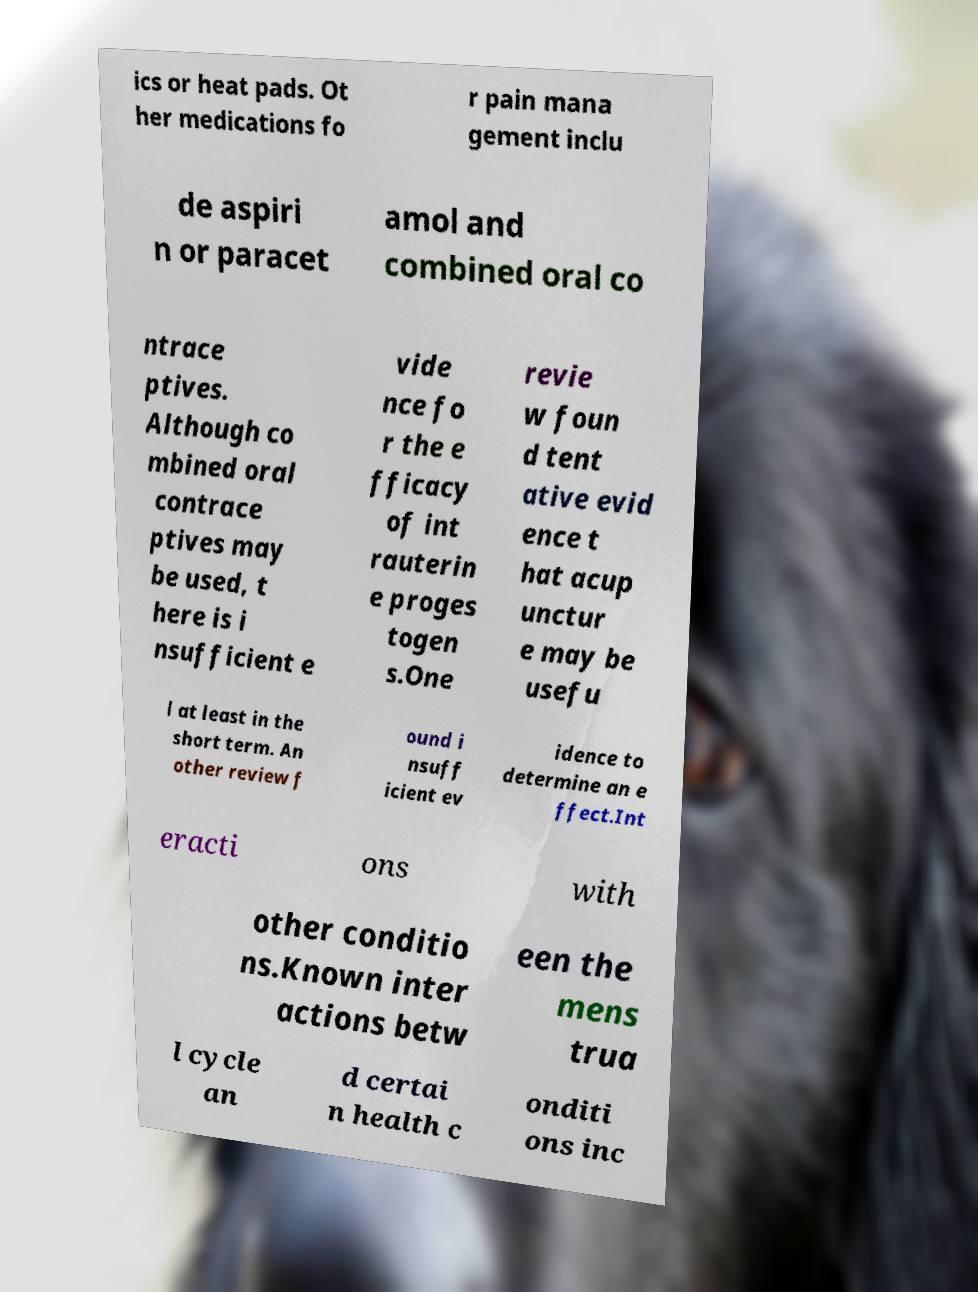Please read and relay the text visible in this image. What does it say? ics or heat pads. Ot her medications fo r pain mana gement inclu de aspiri n or paracet amol and combined oral co ntrace ptives. Although co mbined oral contrace ptives may be used, t here is i nsufficient e vide nce fo r the e fficacy of int rauterin e proges togen s.One revie w foun d tent ative evid ence t hat acup unctur e may be usefu l at least in the short term. An other review f ound i nsuff icient ev idence to determine an e ffect.Int eracti ons with other conditio ns.Known inter actions betw een the mens trua l cycle an d certai n health c onditi ons inc 